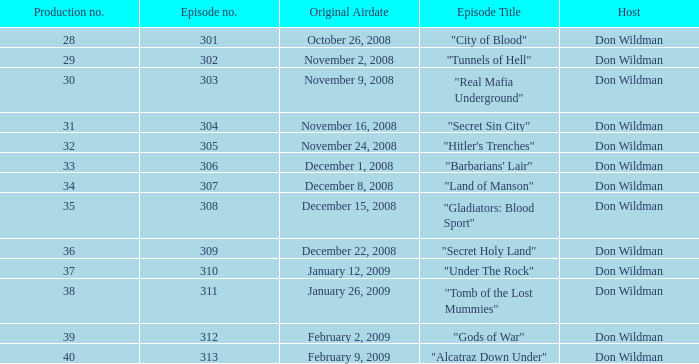What is the episode number of the episode that originally aired on January 26, 2009 and had a production number smaller than 38? 0.0. 